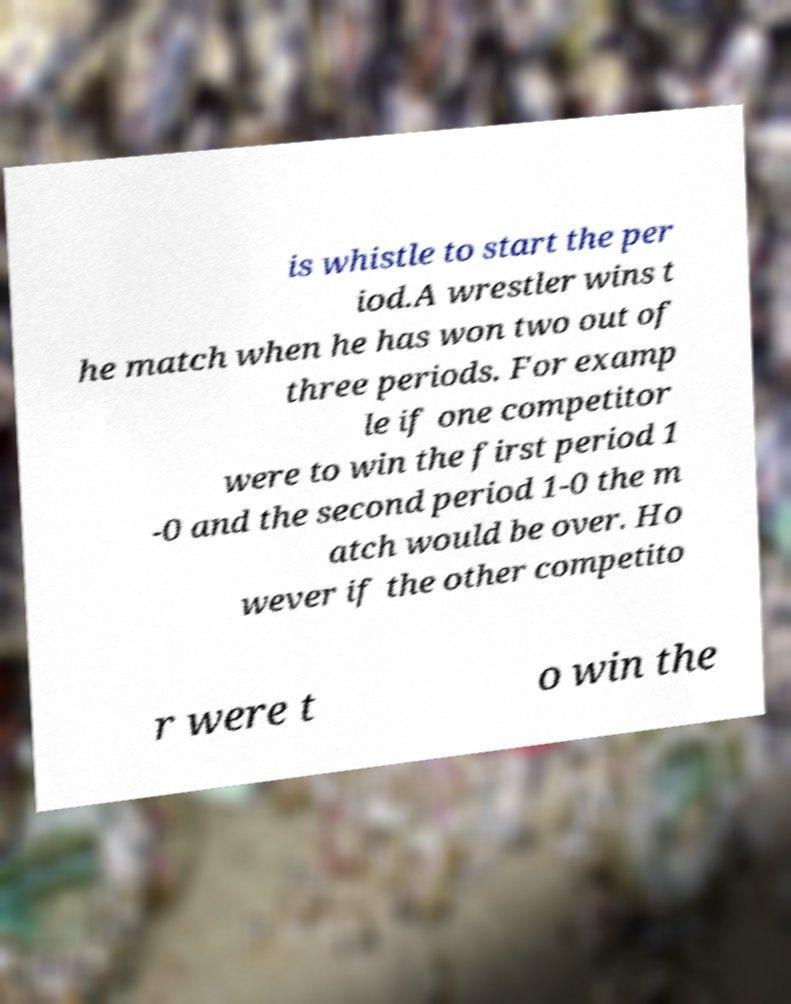Please read and relay the text visible in this image. What does it say? is whistle to start the per iod.A wrestler wins t he match when he has won two out of three periods. For examp le if one competitor were to win the first period 1 -0 and the second period 1-0 the m atch would be over. Ho wever if the other competito r were t o win the 